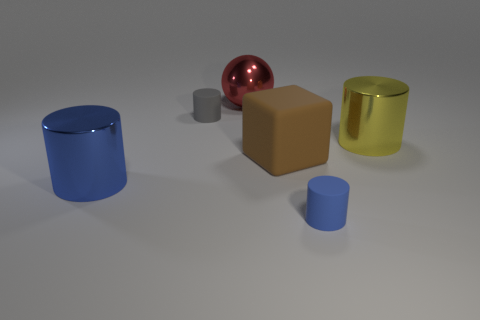How many things are large yellow metal things or metal cylinders that are behind the brown matte thing?
Your answer should be compact. 1. Does the metallic cylinder that is behind the blue shiny thing have the same size as the blue metallic cylinder?
Provide a succinct answer. Yes. What number of other things are the same shape as the small gray object?
Provide a short and direct response. 3. How many yellow things are either rubber cylinders or large metal spheres?
Your response must be concise. 0. Do the tiny matte cylinder that is to the right of the red ball and the sphere have the same color?
Provide a succinct answer. No. What is the shape of the blue thing that is the same material as the big yellow cylinder?
Make the answer very short. Cylinder. What is the color of the cylinder that is both in front of the big rubber thing and behind the tiny blue matte cylinder?
Offer a terse response. Blue. There is a shiny thing on the right side of the blue cylinder that is right of the large brown matte object; how big is it?
Offer a terse response. Large. Is there a sphere of the same color as the large rubber thing?
Provide a short and direct response. No. Are there an equal number of small rubber objects that are to the right of the large rubber cube and gray metallic spheres?
Ensure brevity in your answer.  No. 